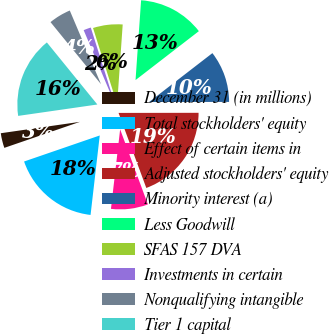Convert chart to OTSL. <chart><loc_0><loc_0><loc_500><loc_500><pie_chart><fcel>December 31 (in millions)<fcel>Total stockholders' equity<fcel>Effect of certain items in<fcel>Adjusted stockholders' equity<fcel>Minority interest (a)<fcel>Less Goodwill<fcel>SFAS 157 DVA<fcel>Investments in certain<fcel>Nonqualifying intangible<fcel>Tier 1 capital<nl><fcel>3.0%<fcel>17.9%<fcel>7.47%<fcel>19.39%<fcel>10.45%<fcel>13.43%<fcel>5.98%<fcel>1.51%<fcel>4.49%<fcel>16.41%<nl></chart> 